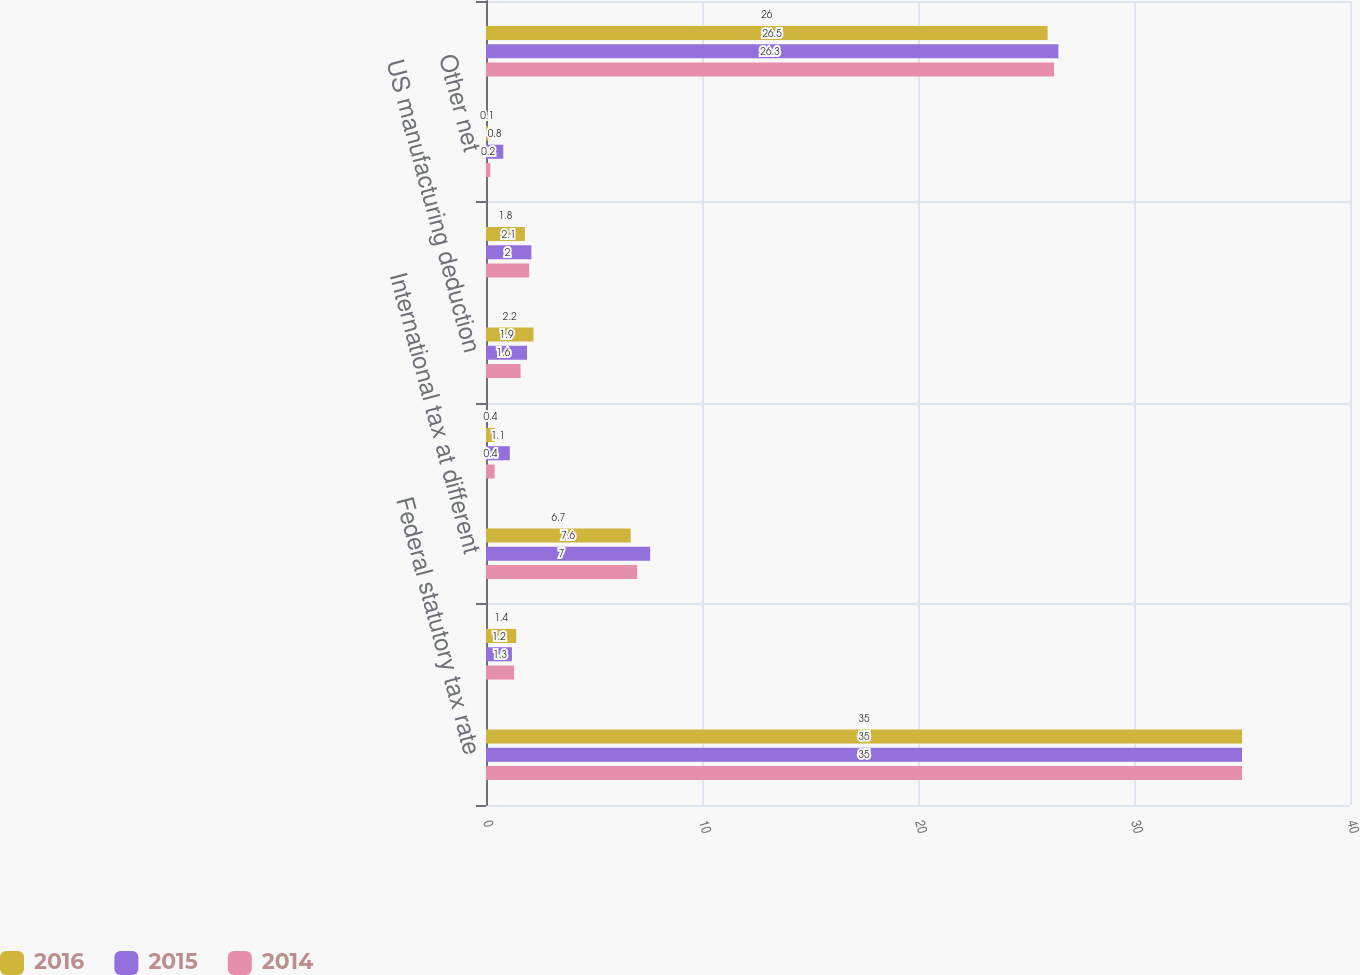<chart> <loc_0><loc_0><loc_500><loc_500><stacked_bar_chart><ecel><fcel>Federal statutory tax rate<fcel>State income taxes net of<fcel>International tax at different<fcel>US tax on remitted and<fcel>US manufacturing deduction<fcel>Changes in prior year tax<fcel>Other net<fcel>Total<nl><fcel>2016<fcel>35<fcel>1.4<fcel>6.7<fcel>0.4<fcel>2.2<fcel>1.8<fcel>0.1<fcel>26<nl><fcel>2015<fcel>35<fcel>1.2<fcel>7.6<fcel>1.1<fcel>1.9<fcel>2.1<fcel>0.8<fcel>26.5<nl><fcel>2014<fcel>35<fcel>1.3<fcel>7<fcel>0.4<fcel>1.6<fcel>2<fcel>0.2<fcel>26.3<nl></chart> 